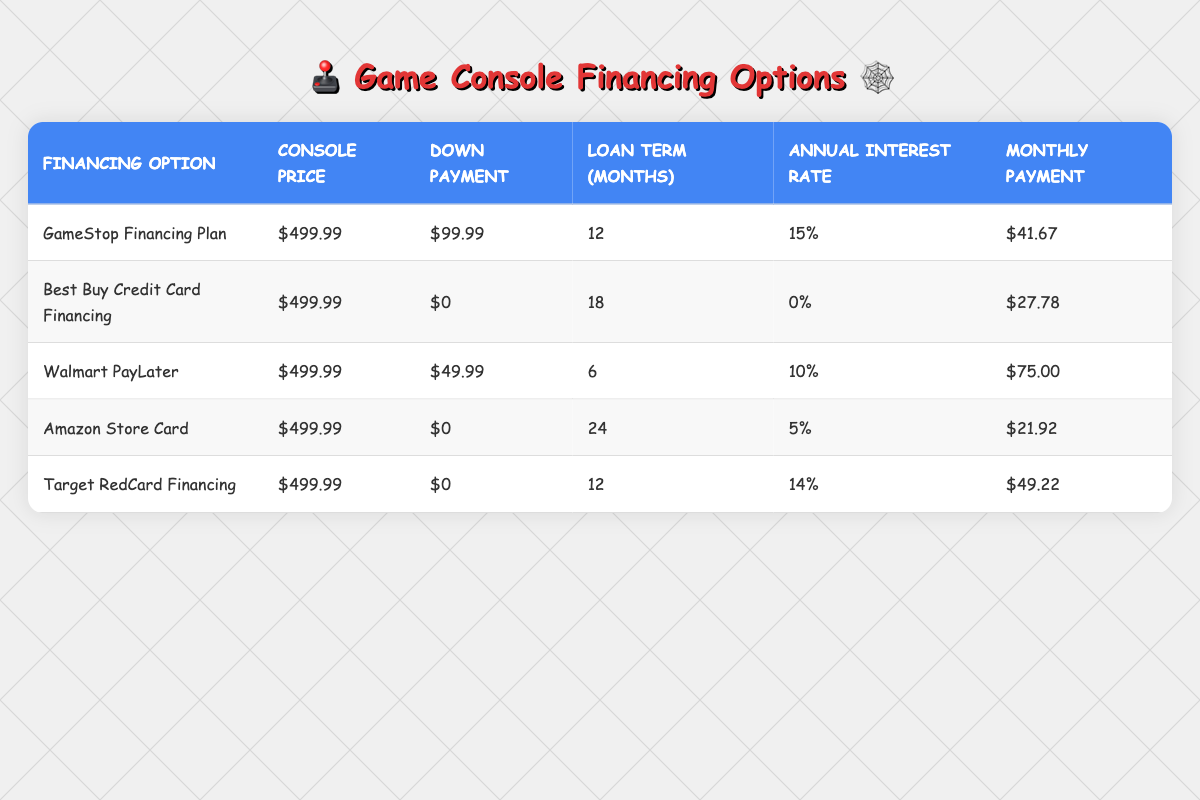What's the monthly payment for the Best Buy Credit Card Financing option? The Best Buy Credit Card Financing option has a monthly payment listed in the table. It states $27.78 as the monthly payment for this option.
Answer: 27.78 How much is the down payment required for the GameStop Financing Plan? The down payment for the GameStop Financing Plan is directly listed in the table as $99.99.
Answer: 99.99 Which financing option has the highest monthly payment? To find which financing option has the highest monthly payment, compare all listed monthly payments. Walmart PayLater has the highest monthly payment at $75.00.
Answer: Walmart PayLater What is the total console price after the down payment for the Amazon Store Card option? The table lists the console price as $499.99 and the down payment as $0 for the Amazon Store Card. Therefore, the total remains $499.99 because no down payment is made.
Answer: 499.99 Is the annual interest rate for the Amazon Store Card higher than that of the Walmart PayLater option? The Amazon Store Card has an annual interest rate of 5%, while Walmart PayLater has an annual interest rate of 10%. Since 5% is lower than 10%, the statement is false.
Answer: No What is the total cost paid at the end of the loan term for the Target RedCard Financing? To find the total cost, multiply the monthly payment of $49.22 by the loan term of 12 months. The calculation is 49.22 * 12 = $590.64 for the total cost.
Answer: 590.64 Which financing options require a down payment of $0? By reviewing the table, both the Best Buy Credit Card Financing and the Amazon Store Card options indicate a down payment of $0.
Answer: Best Buy Credit Card Financing and Amazon Store Card What’s the average monthly payment across all financing options in the table? To find the average, add all the monthly payments: 41.67 + 27.78 + 75.00 + 21.92 + 49.22 = 215.59. There are 5 options, so the average is 215.59 / 5 = 43.12.
Answer: 43.12 Which financing option has the longest loan term? By examining the table, the Amazon Store Card has a loan term of 24 months, which is longer than any other option listed.
Answer: Amazon Store Card 